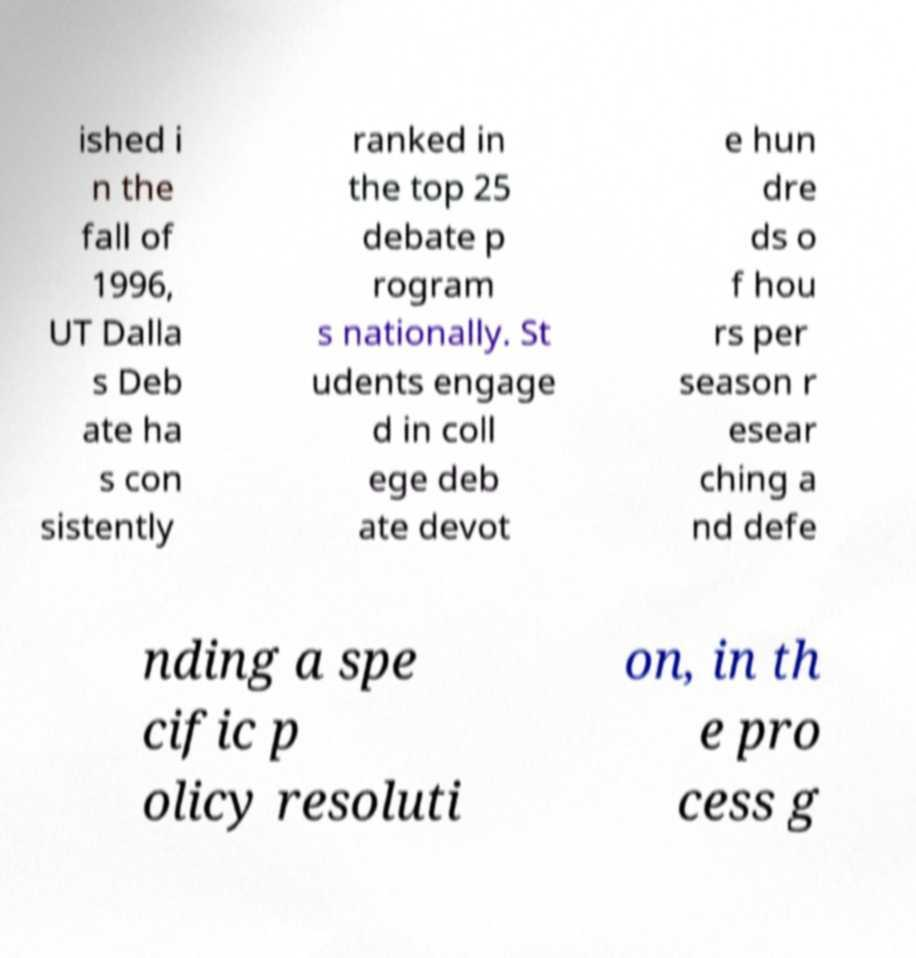I need the written content from this picture converted into text. Can you do that? ished i n the fall of 1996, UT Dalla s Deb ate ha s con sistently ranked in the top 25 debate p rogram s nationally. St udents engage d in coll ege deb ate devot e hun dre ds o f hou rs per season r esear ching a nd defe nding a spe cific p olicy resoluti on, in th e pro cess g 